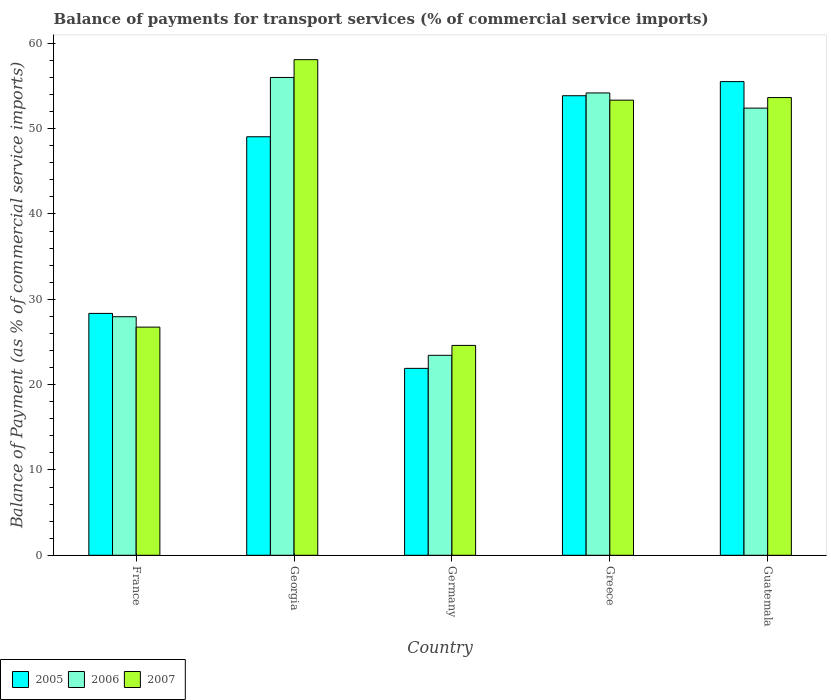How many different coloured bars are there?
Provide a succinct answer. 3. How many groups of bars are there?
Give a very brief answer. 5. Are the number of bars per tick equal to the number of legend labels?
Give a very brief answer. Yes. Are the number of bars on each tick of the X-axis equal?
Give a very brief answer. Yes. How many bars are there on the 1st tick from the left?
Ensure brevity in your answer.  3. How many bars are there on the 4th tick from the right?
Your answer should be compact. 3. What is the label of the 2nd group of bars from the left?
Make the answer very short. Georgia. What is the balance of payments for transport services in 2005 in Germany?
Give a very brief answer. 21.91. Across all countries, what is the maximum balance of payments for transport services in 2005?
Your answer should be compact. 55.52. Across all countries, what is the minimum balance of payments for transport services in 2005?
Provide a succinct answer. 21.91. In which country was the balance of payments for transport services in 2005 maximum?
Make the answer very short. Guatemala. What is the total balance of payments for transport services in 2007 in the graph?
Offer a very short reply. 216.41. What is the difference between the balance of payments for transport services in 2006 in Georgia and that in Germany?
Ensure brevity in your answer.  32.56. What is the difference between the balance of payments for transport services in 2006 in France and the balance of payments for transport services in 2007 in Greece?
Offer a terse response. -25.38. What is the average balance of payments for transport services in 2006 per country?
Keep it short and to the point. 42.8. What is the difference between the balance of payments for transport services of/in 2006 and balance of payments for transport services of/in 2005 in Guatemala?
Give a very brief answer. -3.11. In how many countries, is the balance of payments for transport services in 2007 greater than 22 %?
Make the answer very short. 5. What is the ratio of the balance of payments for transport services in 2006 in Germany to that in Greece?
Your answer should be very brief. 0.43. Is the balance of payments for transport services in 2007 in Georgia less than that in Guatemala?
Make the answer very short. No. What is the difference between the highest and the second highest balance of payments for transport services in 2006?
Your answer should be very brief. 3.59. What is the difference between the highest and the lowest balance of payments for transport services in 2007?
Provide a succinct answer. 33.49. In how many countries, is the balance of payments for transport services in 2005 greater than the average balance of payments for transport services in 2005 taken over all countries?
Your response must be concise. 3. What does the 3rd bar from the right in Georgia represents?
Provide a short and direct response. 2005. How many bars are there?
Offer a very short reply. 15. Are all the bars in the graph horizontal?
Provide a short and direct response. No. How many countries are there in the graph?
Provide a short and direct response. 5. Does the graph contain grids?
Offer a terse response. No. Where does the legend appear in the graph?
Provide a short and direct response. Bottom left. How are the legend labels stacked?
Your answer should be compact. Horizontal. What is the title of the graph?
Your answer should be compact. Balance of payments for transport services (% of commercial service imports). What is the label or title of the X-axis?
Provide a short and direct response. Country. What is the label or title of the Y-axis?
Provide a short and direct response. Balance of Payment (as % of commercial service imports). What is the Balance of Payment (as % of commercial service imports) in 2005 in France?
Offer a very short reply. 28.35. What is the Balance of Payment (as % of commercial service imports) in 2006 in France?
Your answer should be compact. 27.96. What is the Balance of Payment (as % of commercial service imports) of 2007 in France?
Your response must be concise. 26.74. What is the Balance of Payment (as % of commercial service imports) in 2005 in Georgia?
Offer a very short reply. 49.05. What is the Balance of Payment (as % of commercial service imports) of 2006 in Georgia?
Your response must be concise. 56. What is the Balance of Payment (as % of commercial service imports) of 2007 in Georgia?
Provide a short and direct response. 58.09. What is the Balance of Payment (as % of commercial service imports) in 2005 in Germany?
Your answer should be compact. 21.91. What is the Balance of Payment (as % of commercial service imports) in 2006 in Germany?
Give a very brief answer. 23.44. What is the Balance of Payment (as % of commercial service imports) of 2007 in Germany?
Your answer should be very brief. 24.6. What is the Balance of Payment (as % of commercial service imports) of 2005 in Greece?
Your answer should be very brief. 53.86. What is the Balance of Payment (as % of commercial service imports) of 2006 in Greece?
Provide a succinct answer. 54.19. What is the Balance of Payment (as % of commercial service imports) of 2007 in Greece?
Provide a short and direct response. 53.34. What is the Balance of Payment (as % of commercial service imports) in 2005 in Guatemala?
Your answer should be very brief. 55.52. What is the Balance of Payment (as % of commercial service imports) of 2006 in Guatemala?
Give a very brief answer. 52.41. What is the Balance of Payment (as % of commercial service imports) of 2007 in Guatemala?
Provide a succinct answer. 53.64. Across all countries, what is the maximum Balance of Payment (as % of commercial service imports) of 2005?
Ensure brevity in your answer.  55.52. Across all countries, what is the maximum Balance of Payment (as % of commercial service imports) in 2006?
Offer a terse response. 56. Across all countries, what is the maximum Balance of Payment (as % of commercial service imports) in 2007?
Your response must be concise. 58.09. Across all countries, what is the minimum Balance of Payment (as % of commercial service imports) in 2005?
Provide a short and direct response. 21.91. Across all countries, what is the minimum Balance of Payment (as % of commercial service imports) in 2006?
Your response must be concise. 23.44. Across all countries, what is the minimum Balance of Payment (as % of commercial service imports) in 2007?
Give a very brief answer. 24.6. What is the total Balance of Payment (as % of commercial service imports) in 2005 in the graph?
Ensure brevity in your answer.  208.68. What is the total Balance of Payment (as % of commercial service imports) of 2006 in the graph?
Keep it short and to the point. 213.99. What is the total Balance of Payment (as % of commercial service imports) of 2007 in the graph?
Your answer should be very brief. 216.41. What is the difference between the Balance of Payment (as % of commercial service imports) of 2005 in France and that in Georgia?
Provide a short and direct response. -20.7. What is the difference between the Balance of Payment (as % of commercial service imports) in 2006 in France and that in Georgia?
Provide a succinct answer. -28.04. What is the difference between the Balance of Payment (as % of commercial service imports) in 2007 in France and that in Georgia?
Your response must be concise. -31.35. What is the difference between the Balance of Payment (as % of commercial service imports) in 2005 in France and that in Germany?
Keep it short and to the point. 6.44. What is the difference between the Balance of Payment (as % of commercial service imports) in 2006 in France and that in Germany?
Offer a terse response. 4.52. What is the difference between the Balance of Payment (as % of commercial service imports) of 2007 in France and that in Germany?
Ensure brevity in your answer.  2.14. What is the difference between the Balance of Payment (as % of commercial service imports) in 2005 in France and that in Greece?
Offer a very short reply. -25.51. What is the difference between the Balance of Payment (as % of commercial service imports) in 2006 in France and that in Greece?
Your response must be concise. -26.23. What is the difference between the Balance of Payment (as % of commercial service imports) of 2007 in France and that in Greece?
Give a very brief answer. -26.6. What is the difference between the Balance of Payment (as % of commercial service imports) of 2005 in France and that in Guatemala?
Provide a succinct answer. -27.17. What is the difference between the Balance of Payment (as % of commercial service imports) of 2006 in France and that in Guatemala?
Provide a short and direct response. -24.45. What is the difference between the Balance of Payment (as % of commercial service imports) in 2007 in France and that in Guatemala?
Your answer should be very brief. -26.9. What is the difference between the Balance of Payment (as % of commercial service imports) of 2005 in Georgia and that in Germany?
Provide a short and direct response. 27.15. What is the difference between the Balance of Payment (as % of commercial service imports) in 2006 in Georgia and that in Germany?
Provide a succinct answer. 32.56. What is the difference between the Balance of Payment (as % of commercial service imports) in 2007 in Georgia and that in Germany?
Give a very brief answer. 33.49. What is the difference between the Balance of Payment (as % of commercial service imports) of 2005 in Georgia and that in Greece?
Provide a succinct answer. -4.81. What is the difference between the Balance of Payment (as % of commercial service imports) in 2006 in Georgia and that in Greece?
Ensure brevity in your answer.  1.82. What is the difference between the Balance of Payment (as % of commercial service imports) of 2007 in Georgia and that in Greece?
Make the answer very short. 4.75. What is the difference between the Balance of Payment (as % of commercial service imports) in 2005 in Georgia and that in Guatemala?
Your answer should be compact. -6.46. What is the difference between the Balance of Payment (as % of commercial service imports) of 2006 in Georgia and that in Guatemala?
Ensure brevity in your answer.  3.59. What is the difference between the Balance of Payment (as % of commercial service imports) of 2007 in Georgia and that in Guatemala?
Offer a terse response. 4.44. What is the difference between the Balance of Payment (as % of commercial service imports) in 2005 in Germany and that in Greece?
Make the answer very short. -31.95. What is the difference between the Balance of Payment (as % of commercial service imports) in 2006 in Germany and that in Greece?
Offer a very short reply. -30.75. What is the difference between the Balance of Payment (as % of commercial service imports) of 2007 in Germany and that in Greece?
Ensure brevity in your answer.  -28.74. What is the difference between the Balance of Payment (as % of commercial service imports) in 2005 in Germany and that in Guatemala?
Offer a very short reply. -33.61. What is the difference between the Balance of Payment (as % of commercial service imports) in 2006 in Germany and that in Guatemala?
Offer a very short reply. -28.97. What is the difference between the Balance of Payment (as % of commercial service imports) in 2007 in Germany and that in Guatemala?
Keep it short and to the point. -29.05. What is the difference between the Balance of Payment (as % of commercial service imports) in 2005 in Greece and that in Guatemala?
Provide a succinct answer. -1.66. What is the difference between the Balance of Payment (as % of commercial service imports) in 2006 in Greece and that in Guatemala?
Your answer should be compact. 1.78. What is the difference between the Balance of Payment (as % of commercial service imports) in 2007 in Greece and that in Guatemala?
Offer a very short reply. -0.3. What is the difference between the Balance of Payment (as % of commercial service imports) in 2005 in France and the Balance of Payment (as % of commercial service imports) in 2006 in Georgia?
Make the answer very short. -27.65. What is the difference between the Balance of Payment (as % of commercial service imports) of 2005 in France and the Balance of Payment (as % of commercial service imports) of 2007 in Georgia?
Give a very brief answer. -29.74. What is the difference between the Balance of Payment (as % of commercial service imports) of 2006 in France and the Balance of Payment (as % of commercial service imports) of 2007 in Georgia?
Make the answer very short. -30.13. What is the difference between the Balance of Payment (as % of commercial service imports) of 2005 in France and the Balance of Payment (as % of commercial service imports) of 2006 in Germany?
Offer a very short reply. 4.91. What is the difference between the Balance of Payment (as % of commercial service imports) in 2005 in France and the Balance of Payment (as % of commercial service imports) in 2007 in Germany?
Offer a terse response. 3.75. What is the difference between the Balance of Payment (as % of commercial service imports) of 2006 in France and the Balance of Payment (as % of commercial service imports) of 2007 in Germany?
Provide a short and direct response. 3.36. What is the difference between the Balance of Payment (as % of commercial service imports) of 2005 in France and the Balance of Payment (as % of commercial service imports) of 2006 in Greece?
Your response must be concise. -25.84. What is the difference between the Balance of Payment (as % of commercial service imports) in 2005 in France and the Balance of Payment (as % of commercial service imports) in 2007 in Greece?
Offer a terse response. -24.99. What is the difference between the Balance of Payment (as % of commercial service imports) in 2006 in France and the Balance of Payment (as % of commercial service imports) in 2007 in Greece?
Provide a short and direct response. -25.38. What is the difference between the Balance of Payment (as % of commercial service imports) of 2005 in France and the Balance of Payment (as % of commercial service imports) of 2006 in Guatemala?
Your response must be concise. -24.06. What is the difference between the Balance of Payment (as % of commercial service imports) in 2005 in France and the Balance of Payment (as % of commercial service imports) in 2007 in Guatemala?
Offer a very short reply. -25.3. What is the difference between the Balance of Payment (as % of commercial service imports) in 2006 in France and the Balance of Payment (as % of commercial service imports) in 2007 in Guatemala?
Make the answer very short. -25.68. What is the difference between the Balance of Payment (as % of commercial service imports) of 2005 in Georgia and the Balance of Payment (as % of commercial service imports) of 2006 in Germany?
Your answer should be very brief. 25.61. What is the difference between the Balance of Payment (as % of commercial service imports) of 2005 in Georgia and the Balance of Payment (as % of commercial service imports) of 2007 in Germany?
Your answer should be very brief. 24.46. What is the difference between the Balance of Payment (as % of commercial service imports) in 2006 in Georgia and the Balance of Payment (as % of commercial service imports) in 2007 in Germany?
Your answer should be very brief. 31.4. What is the difference between the Balance of Payment (as % of commercial service imports) of 2005 in Georgia and the Balance of Payment (as % of commercial service imports) of 2006 in Greece?
Make the answer very short. -5.13. What is the difference between the Balance of Payment (as % of commercial service imports) in 2005 in Georgia and the Balance of Payment (as % of commercial service imports) in 2007 in Greece?
Your response must be concise. -4.29. What is the difference between the Balance of Payment (as % of commercial service imports) in 2006 in Georgia and the Balance of Payment (as % of commercial service imports) in 2007 in Greece?
Ensure brevity in your answer.  2.66. What is the difference between the Balance of Payment (as % of commercial service imports) of 2005 in Georgia and the Balance of Payment (as % of commercial service imports) of 2006 in Guatemala?
Give a very brief answer. -3.36. What is the difference between the Balance of Payment (as % of commercial service imports) of 2005 in Georgia and the Balance of Payment (as % of commercial service imports) of 2007 in Guatemala?
Ensure brevity in your answer.  -4.59. What is the difference between the Balance of Payment (as % of commercial service imports) in 2006 in Georgia and the Balance of Payment (as % of commercial service imports) in 2007 in Guatemala?
Give a very brief answer. 2.36. What is the difference between the Balance of Payment (as % of commercial service imports) of 2005 in Germany and the Balance of Payment (as % of commercial service imports) of 2006 in Greece?
Provide a succinct answer. -32.28. What is the difference between the Balance of Payment (as % of commercial service imports) of 2005 in Germany and the Balance of Payment (as % of commercial service imports) of 2007 in Greece?
Offer a very short reply. -31.43. What is the difference between the Balance of Payment (as % of commercial service imports) in 2006 in Germany and the Balance of Payment (as % of commercial service imports) in 2007 in Greece?
Offer a terse response. -29.9. What is the difference between the Balance of Payment (as % of commercial service imports) of 2005 in Germany and the Balance of Payment (as % of commercial service imports) of 2006 in Guatemala?
Your response must be concise. -30.5. What is the difference between the Balance of Payment (as % of commercial service imports) in 2005 in Germany and the Balance of Payment (as % of commercial service imports) in 2007 in Guatemala?
Ensure brevity in your answer.  -31.74. What is the difference between the Balance of Payment (as % of commercial service imports) of 2006 in Germany and the Balance of Payment (as % of commercial service imports) of 2007 in Guatemala?
Your answer should be very brief. -30.21. What is the difference between the Balance of Payment (as % of commercial service imports) in 2005 in Greece and the Balance of Payment (as % of commercial service imports) in 2006 in Guatemala?
Make the answer very short. 1.45. What is the difference between the Balance of Payment (as % of commercial service imports) in 2005 in Greece and the Balance of Payment (as % of commercial service imports) in 2007 in Guatemala?
Offer a very short reply. 0.22. What is the difference between the Balance of Payment (as % of commercial service imports) in 2006 in Greece and the Balance of Payment (as % of commercial service imports) in 2007 in Guatemala?
Keep it short and to the point. 0.54. What is the average Balance of Payment (as % of commercial service imports) in 2005 per country?
Make the answer very short. 41.74. What is the average Balance of Payment (as % of commercial service imports) in 2006 per country?
Your response must be concise. 42.8. What is the average Balance of Payment (as % of commercial service imports) in 2007 per country?
Your response must be concise. 43.28. What is the difference between the Balance of Payment (as % of commercial service imports) in 2005 and Balance of Payment (as % of commercial service imports) in 2006 in France?
Keep it short and to the point. 0.39. What is the difference between the Balance of Payment (as % of commercial service imports) of 2005 and Balance of Payment (as % of commercial service imports) of 2007 in France?
Ensure brevity in your answer.  1.61. What is the difference between the Balance of Payment (as % of commercial service imports) of 2006 and Balance of Payment (as % of commercial service imports) of 2007 in France?
Make the answer very short. 1.22. What is the difference between the Balance of Payment (as % of commercial service imports) in 2005 and Balance of Payment (as % of commercial service imports) in 2006 in Georgia?
Offer a very short reply. -6.95. What is the difference between the Balance of Payment (as % of commercial service imports) in 2005 and Balance of Payment (as % of commercial service imports) in 2007 in Georgia?
Your answer should be very brief. -9.04. What is the difference between the Balance of Payment (as % of commercial service imports) of 2006 and Balance of Payment (as % of commercial service imports) of 2007 in Georgia?
Your response must be concise. -2.09. What is the difference between the Balance of Payment (as % of commercial service imports) of 2005 and Balance of Payment (as % of commercial service imports) of 2006 in Germany?
Give a very brief answer. -1.53. What is the difference between the Balance of Payment (as % of commercial service imports) in 2005 and Balance of Payment (as % of commercial service imports) in 2007 in Germany?
Give a very brief answer. -2.69. What is the difference between the Balance of Payment (as % of commercial service imports) in 2006 and Balance of Payment (as % of commercial service imports) in 2007 in Germany?
Offer a terse response. -1.16. What is the difference between the Balance of Payment (as % of commercial service imports) in 2005 and Balance of Payment (as % of commercial service imports) in 2006 in Greece?
Your answer should be compact. -0.33. What is the difference between the Balance of Payment (as % of commercial service imports) of 2005 and Balance of Payment (as % of commercial service imports) of 2007 in Greece?
Offer a very short reply. 0.52. What is the difference between the Balance of Payment (as % of commercial service imports) in 2006 and Balance of Payment (as % of commercial service imports) in 2007 in Greece?
Give a very brief answer. 0.85. What is the difference between the Balance of Payment (as % of commercial service imports) in 2005 and Balance of Payment (as % of commercial service imports) in 2006 in Guatemala?
Keep it short and to the point. 3.11. What is the difference between the Balance of Payment (as % of commercial service imports) in 2005 and Balance of Payment (as % of commercial service imports) in 2007 in Guatemala?
Make the answer very short. 1.87. What is the difference between the Balance of Payment (as % of commercial service imports) in 2006 and Balance of Payment (as % of commercial service imports) in 2007 in Guatemala?
Keep it short and to the point. -1.24. What is the ratio of the Balance of Payment (as % of commercial service imports) of 2005 in France to that in Georgia?
Ensure brevity in your answer.  0.58. What is the ratio of the Balance of Payment (as % of commercial service imports) of 2006 in France to that in Georgia?
Your response must be concise. 0.5. What is the ratio of the Balance of Payment (as % of commercial service imports) of 2007 in France to that in Georgia?
Make the answer very short. 0.46. What is the ratio of the Balance of Payment (as % of commercial service imports) in 2005 in France to that in Germany?
Provide a succinct answer. 1.29. What is the ratio of the Balance of Payment (as % of commercial service imports) in 2006 in France to that in Germany?
Provide a short and direct response. 1.19. What is the ratio of the Balance of Payment (as % of commercial service imports) of 2007 in France to that in Germany?
Ensure brevity in your answer.  1.09. What is the ratio of the Balance of Payment (as % of commercial service imports) in 2005 in France to that in Greece?
Offer a very short reply. 0.53. What is the ratio of the Balance of Payment (as % of commercial service imports) of 2006 in France to that in Greece?
Your answer should be very brief. 0.52. What is the ratio of the Balance of Payment (as % of commercial service imports) of 2007 in France to that in Greece?
Your response must be concise. 0.5. What is the ratio of the Balance of Payment (as % of commercial service imports) of 2005 in France to that in Guatemala?
Your response must be concise. 0.51. What is the ratio of the Balance of Payment (as % of commercial service imports) of 2006 in France to that in Guatemala?
Your answer should be very brief. 0.53. What is the ratio of the Balance of Payment (as % of commercial service imports) of 2007 in France to that in Guatemala?
Your answer should be compact. 0.5. What is the ratio of the Balance of Payment (as % of commercial service imports) of 2005 in Georgia to that in Germany?
Your answer should be compact. 2.24. What is the ratio of the Balance of Payment (as % of commercial service imports) of 2006 in Georgia to that in Germany?
Give a very brief answer. 2.39. What is the ratio of the Balance of Payment (as % of commercial service imports) of 2007 in Georgia to that in Germany?
Your answer should be compact. 2.36. What is the ratio of the Balance of Payment (as % of commercial service imports) of 2005 in Georgia to that in Greece?
Provide a short and direct response. 0.91. What is the ratio of the Balance of Payment (as % of commercial service imports) in 2006 in Georgia to that in Greece?
Give a very brief answer. 1.03. What is the ratio of the Balance of Payment (as % of commercial service imports) of 2007 in Georgia to that in Greece?
Make the answer very short. 1.09. What is the ratio of the Balance of Payment (as % of commercial service imports) in 2005 in Georgia to that in Guatemala?
Your answer should be very brief. 0.88. What is the ratio of the Balance of Payment (as % of commercial service imports) of 2006 in Georgia to that in Guatemala?
Make the answer very short. 1.07. What is the ratio of the Balance of Payment (as % of commercial service imports) of 2007 in Georgia to that in Guatemala?
Give a very brief answer. 1.08. What is the ratio of the Balance of Payment (as % of commercial service imports) in 2005 in Germany to that in Greece?
Your response must be concise. 0.41. What is the ratio of the Balance of Payment (as % of commercial service imports) of 2006 in Germany to that in Greece?
Your answer should be very brief. 0.43. What is the ratio of the Balance of Payment (as % of commercial service imports) of 2007 in Germany to that in Greece?
Offer a very short reply. 0.46. What is the ratio of the Balance of Payment (as % of commercial service imports) of 2005 in Germany to that in Guatemala?
Provide a short and direct response. 0.39. What is the ratio of the Balance of Payment (as % of commercial service imports) of 2006 in Germany to that in Guatemala?
Give a very brief answer. 0.45. What is the ratio of the Balance of Payment (as % of commercial service imports) in 2007 in Germany to that in Guatemala?
Your answer should be very brief. 0.46. What is the ratio of the Balance of Payment (as % of commercial service imports) in 2005 in Greece to that in Guatemala?
Your response must be concise. 0.97. What is the ratio of the Balance of Payment (as % of commercial service imports) of 2006 in Greece to that in Guatemala?
Provide a succinct answer. 1.03. What is the ratio of the Balance of Payment (as % of commercial service imports) in 2007 in Greece to that in Guatemala?
Keep it short and to the point. 0.99. What is the difference between the highest and the second highest Balance of Payment (as % of commercial service imports) in 2005?
Make the answer very short. 1.66. What is the difference between the highest and the second highest Balance of Payment (as % of commercial service imports) of 2006?
Provide a succinct answer. 1.82. What is the difference between the highest and the second highest Balance of Payment (as % of commercial service imports) of 2007?
Offer a terse response. 4.44. What is the difference between the highest and the lowest Balance of Payment (as % of commercial service imports) in 2005?
Give a very brief answer. 33.61. What is the difference between the highest and the lowest Balance of Payment (as % of commercial service imports) of 2006?
Your answer should be compact. 32.56. What is the difference between the highest and the lowest Balance of Payment (as % of commercial service imports) of 2007?
Keep it short and to the point. 33.49. 